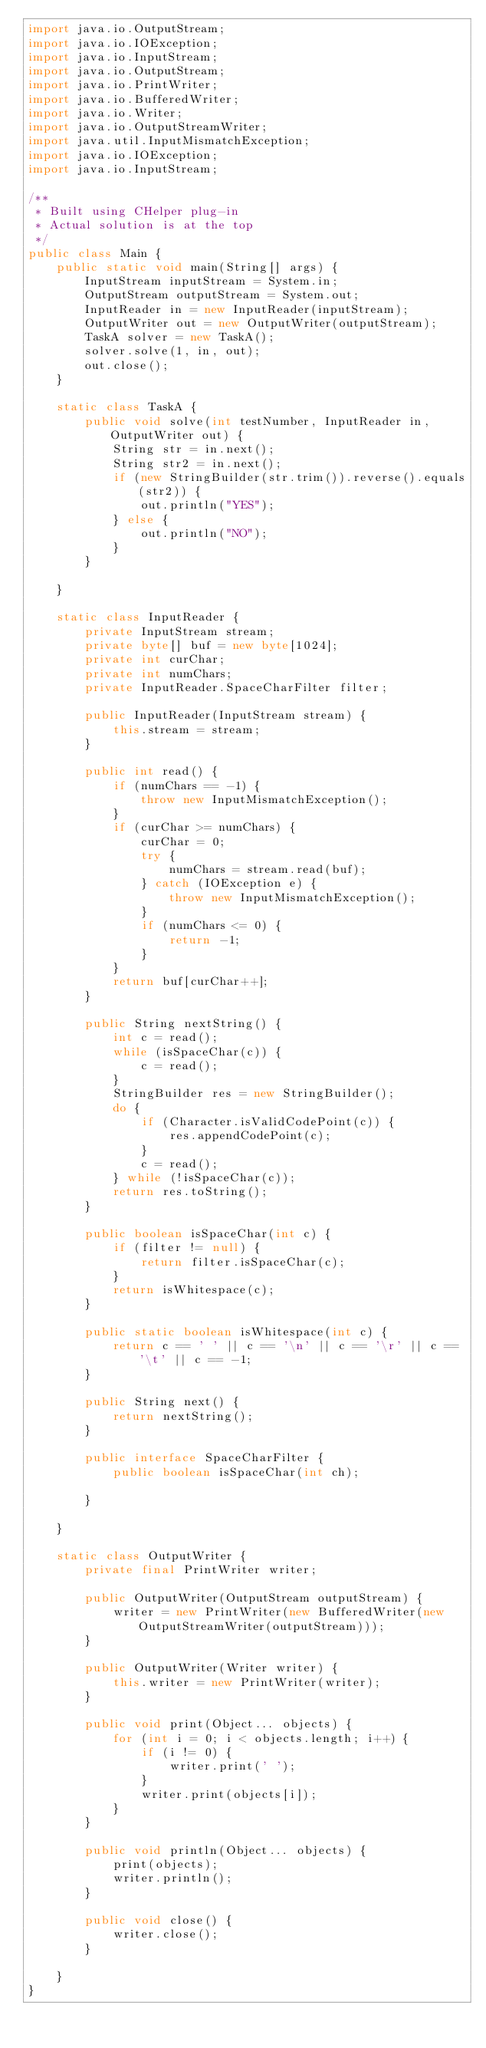<code> <loc_0><loc_0><loc_500><loc_500><_Java_>import java.io.OutputStream;
import java.io.IOException;
import java.io.InputStream;
import java.io.OutputStream;
import java.io.PrintWriter;
import java.io.BufferedWriter;
import java.io.Writer;
import java.io.OutputStreamWriter;
import java.util.InputMismatchException;
import java.io.IOException;
import java.io.InputStream;

/**
 * Built using CHelper plug-in
 * Actual solution is at the top
 */
public class Main {
    public static void main(String[] args) {
        InputStream inputStream = System.in;
        OutputStream outputStream = System.out;
        InputReader in = new InputReader(inputStream);
        OutputWriter out = new OutputWriter(outputStream);
        TaskA solver = new TaskA();
        solver.solve(1, in, out);
        out.close();
    }

    static class TaskA {
        public void solve(int testNumber, InputReader in, OutputWriter out) {
            String str = in.next();
            String str2 = in.next();
            if (new StringBuilder(str.trim()).reverse().equals(str2)) {
                out.println("YES");
            } else {
                out.println("NO");
            }
        }

    }

    static class InputReader {
        private InputStream stream;
        private byte[] buf = new byte[1024];
        private int curChar;
        private int numChars;
        private InputReader.SpaceCharFilter filter;

        public InputReader(InputStream stream) {
            this.stream = stream;
        }

        public int read() {
            if (numChars == -1) {
                throw new InputMismatchException();
            }
            if (curChar >= numChars) {
                curChar = 0;
                try {
                    numChars = stream.read(buf);
                } catch (IOException e) {
                    throw new InputMismatchException();
                }
                if (numChars <= 0) {
                    return -1;
                }
            }
            return buf[curChar++];
        }

        public String nextString() {
            int c = read();
            while (isSpaceChar(c)) {
                c = read();
            }
            StringBuilder res = new StringBuilder();
            do {
                if (Character.isValidCodePoint(c)) {
                    res.appendCodePoint(c);
                }
                c = read();
            } while (!isSpaceChar(c));
            return res.toString();
        }

        public boolean isSpaceChar(int c) {
            if (filter != null) {
                return filter.isSpaceChar(c);
            }
            return isWhitespace(c);
        }

        public static boolean isWhitespace(int c) {
            return c == ' ' || c == '\n' || c == '\r' || c == '\t' || c == -1;
        }

        public String next() {
            return nextString();
        }

        public interface SpaceCharFilter {
            public boolean isSpaceChar(int ch);

        }

    }

    static class OutputWriter {
        private final PrintWriter writer;

        public OutputWriter(OutputStream outputStream) {
            writer = new PrintWriter(new BufferedWriter(new OutputStreamWriter(outputStream)));
        }

        public OutputWriter(Writer writer) {
            this.writer = new PrintWriter(writer);
        }

        public void print(Object... objects) {
            for (int i = 0; i < objects.length; i++) {
                if (i != 0) {
                    writer.print(' ');
                }
                writer.print(objects[i]);
            }
        }

        public void println(Object... objects) {
            print(objects);
            writer.println();
        }

        public void close() {
            writer.close();
        }

    }
}

</code> 